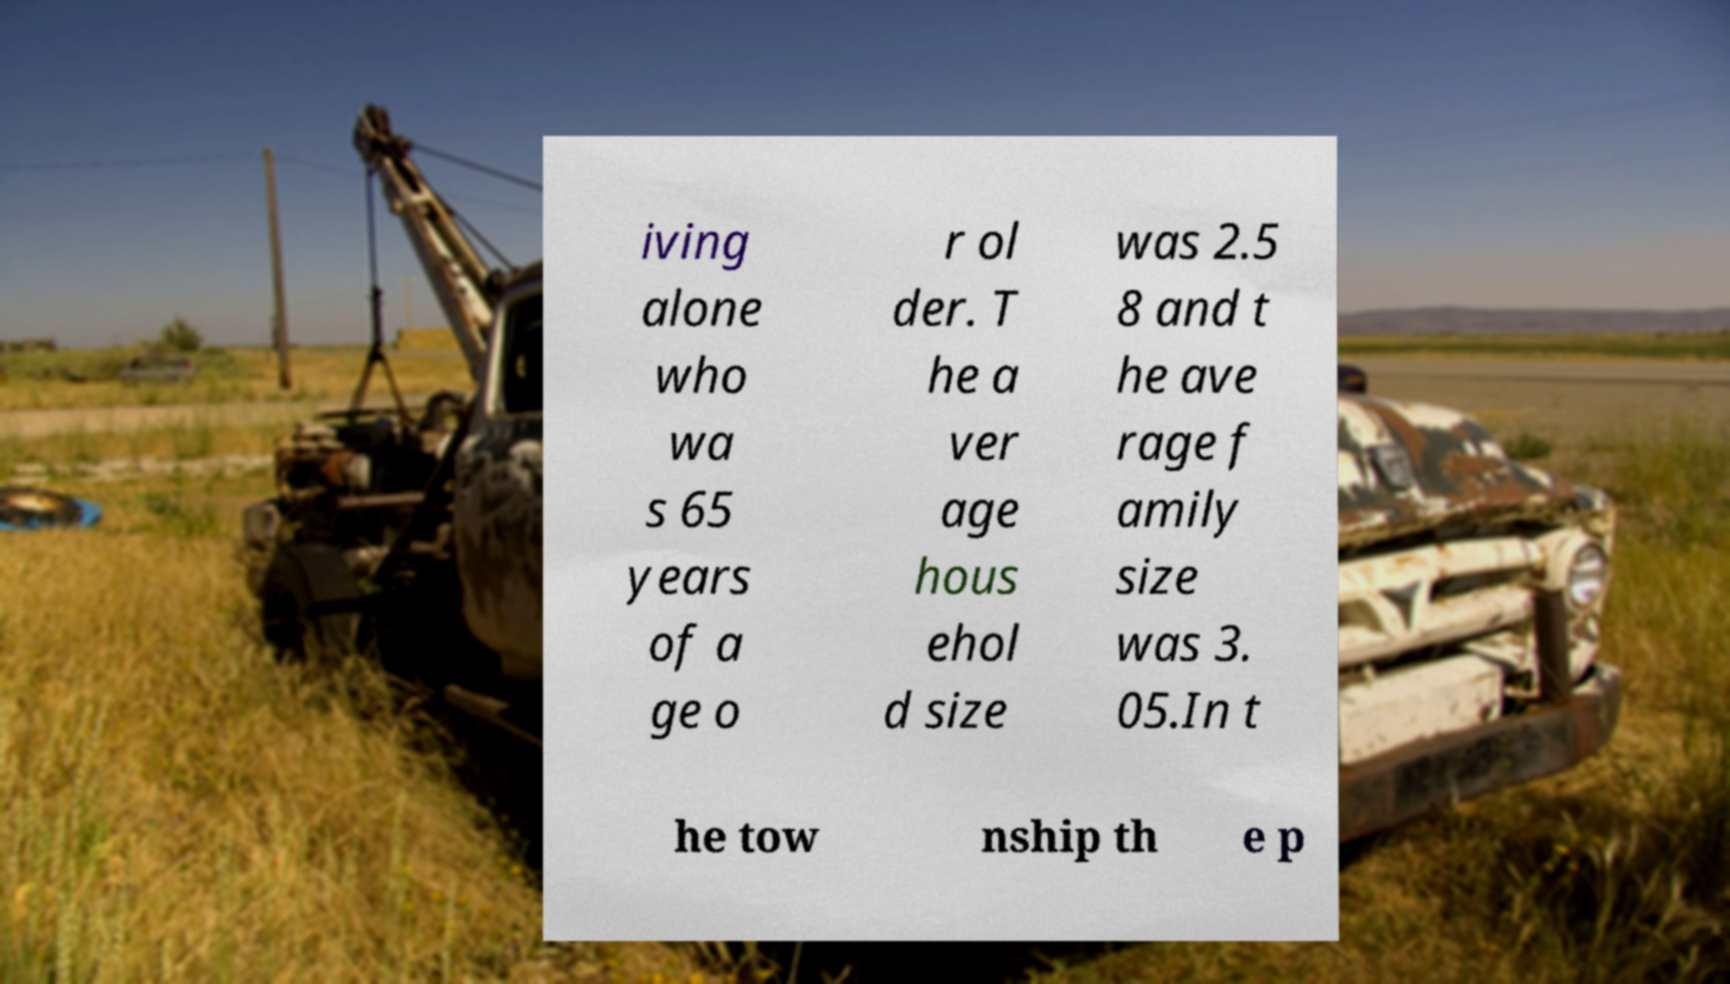There's text embedded in this image that I need extracted. Can you transcribe it verbatim? iving alone who wa s 65 years of a ge o r ol der. T he a ver age hous ehol d size was 2.5 8 and t he ave rage f amily size was 3. 05.In t he tow nship th e p 